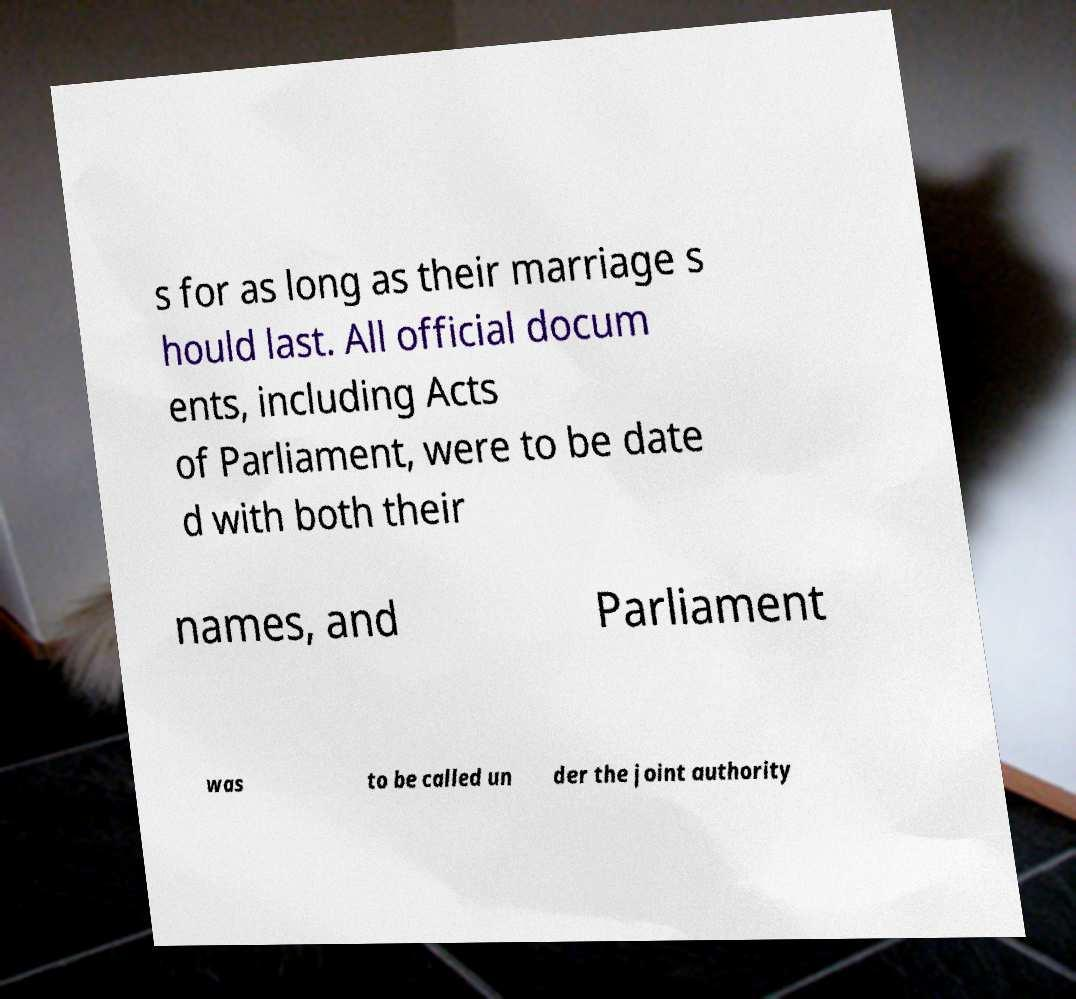For documentation purposes, I need the text within this image transcribed. Could you provide that? s for as long as their marriage s hould last. All official docum ents, including Acts of Parliament, were to be date d with both their names, and Parliament was to be called un der the joint authority 